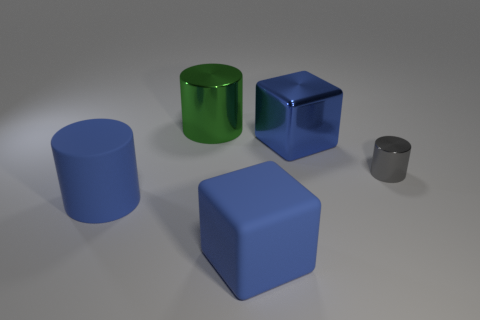Subtract all big blue matte cylinders. How many cylinders are left? 2 Subtract 2 cylinders. How many cylinders are left? 1 Subtract all cubes. How many objects are left? 3 Subtract all gray cylinders. How many gray blocks are left? 0 Subtract all yellow cylinders. Subtract all red cubes. How many cylinders are left? 3 Subtract all big objects. Subtract all big matte cylinders. How many objects are left? 0 Add 5 green shiny cylinders. How many green shiny cylinders are left? 6 Add 1 large cylinders. How many large cylinders exist? 3 Add 3 cylinders. How many objects exist? 8 Subtract 0 brown cylinders. How many objects are left? 5 